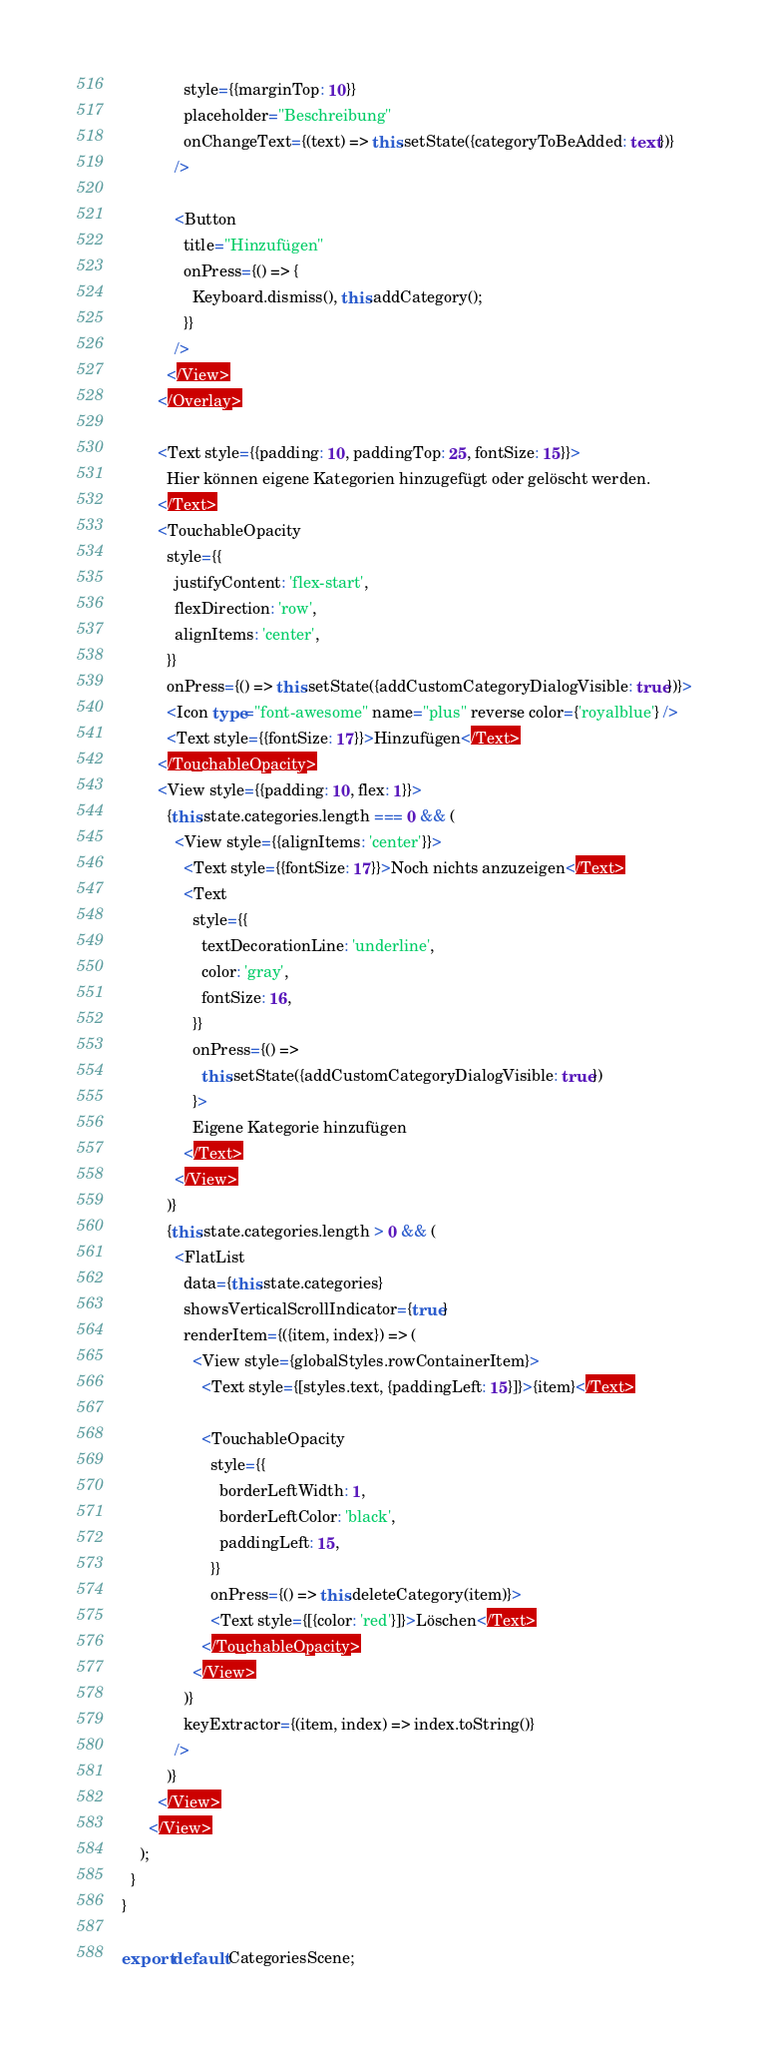Convert code to text. <code><loc_0><loc_0><loc_500><loc_500><_TypeScript_>              style={{marginTop: 10}}
              placeholder="Beschreibung"
              onChangeText={(text) => this.setState({categoryToBeAdded: text})}
            />

            <Button
              title="Hinzufügen"
              onPress={() => {
                Keyboard.dismiss(), this.addCategory();
              }}
            />
          </View>
        </Overlay>

        <Text style={{padding: 10, paddingTop: 25, fontSize: 15}}>
          Hier können eigene Kategorien hinzugefügt oder gelöscht werden.
        </Text>
        <TouchableOpacity
          style={{
            justifyContent: 'flex-start',
            flexDirection: 'row',
            alignItems: 'center',
          }}
          onPress={() => this.setState({addCustomCategoryDialogVisible: true})}>
          <Icon type="font-awesome" name="plus" reverse color={'royalblue'} />
          <Text style={{fontSize: 17}}>Hinzufügen</Text>
        </TouchableOpacity>
        <View style={{padding: 10, flex: 1}}>
          {this.state.categories.length === 0 && (
            <View style={{alignItems: 'center'}}>
              <Text style={{fontSize: 17}}>Noch nichts anzuzeigen</Text>
              <Text
                style={{
                  textDecorationLine: 'underline',
                  color: 'gray',
                  fontSize: 16,
                }}
                onPress={() =>
                  this.setState({addCustomCategoryDialogVisible: true})
                }>
                Eigene Kategorie hinzufügen
              </Text>
            </View>
          )}
          {this.state.categories.length > 0 && (
            <FlatList
              data={this.state.categories}
              showsVerticalScrollIndicator={true}
              renderItem={({item, index}) => (
                <View style={globalStyles.rowContainerItem}>
                  <Text style={[styles.text, {paddingLeft: 15}]}>{item}</Text>

                  <TouchableOpacity
                    style={{
                      borderLeftWidth: 1,
                      borderLeftColor: 'black',
                      paddingLeft: 15,
                    }}
                    onPress={() => this.deleteCategory(item)}>
                    <Text style={[{color: 'red'}]}>Löschen</Text>
                  </TouchableOpacity>
                </View>
              )}
              keyExtractor={(item, index) => index.toString()}
            />
          )}
        </View>
      </View>
    );
  }
}

export default CategoriesScene;
</code> 